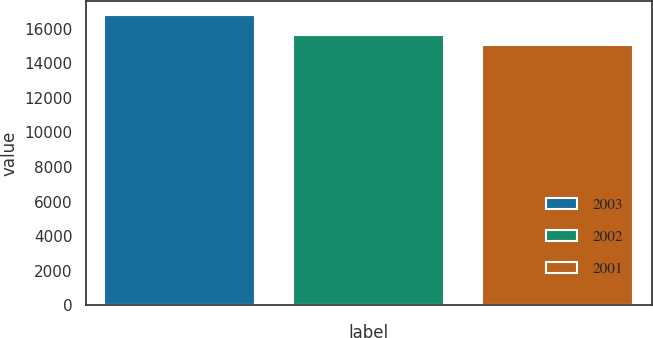Convert chart to OTSL. <chart><loc_0><loc_0><loc_500><loc_500><bar_chart><fcel>2003<fcel>2002<fcel>2001<nl><fcel>16779.9<fcel>15639.6<fcel>15059.1<nl></chart> 